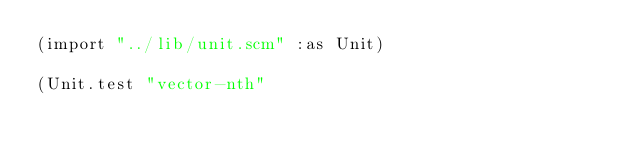Convert code to text. <code><loc_0><loc_0><loc_500><loc_500><_Scheme_>(import "../lib/unit.scm" :as Unit)

(Unit.test "vector-nth"</code> 